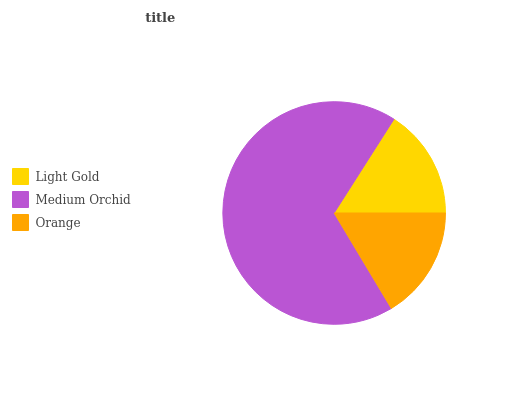Is Light Gold the minimum?
Answer yes or no. Yes. Is Medium Orchid the maximum?
Answer yes or no. Yes. Is Orange the minimum?
Answer yes or no. No. Is Orange the maximum?
Answer yes or no. No. Is Medium Orchid greater than Orange?
Answer yes or no. Yes. Is Orange less than Medium Orchid?
Answer yes or no. Yes. Is Orange greater than Medium Orchid?
Answer yes or no. No. Is Medium Orchid less than Orange?
Answer yes or no. No. Is Orange the high median?
Answer yes or no. Yes. Is Orange the low median?
Answer yes or no. Yes. Is Light Gold the high median?
Answer yes or no. No. Is Medium Orchid the low median?
Answer yes or no. No. 